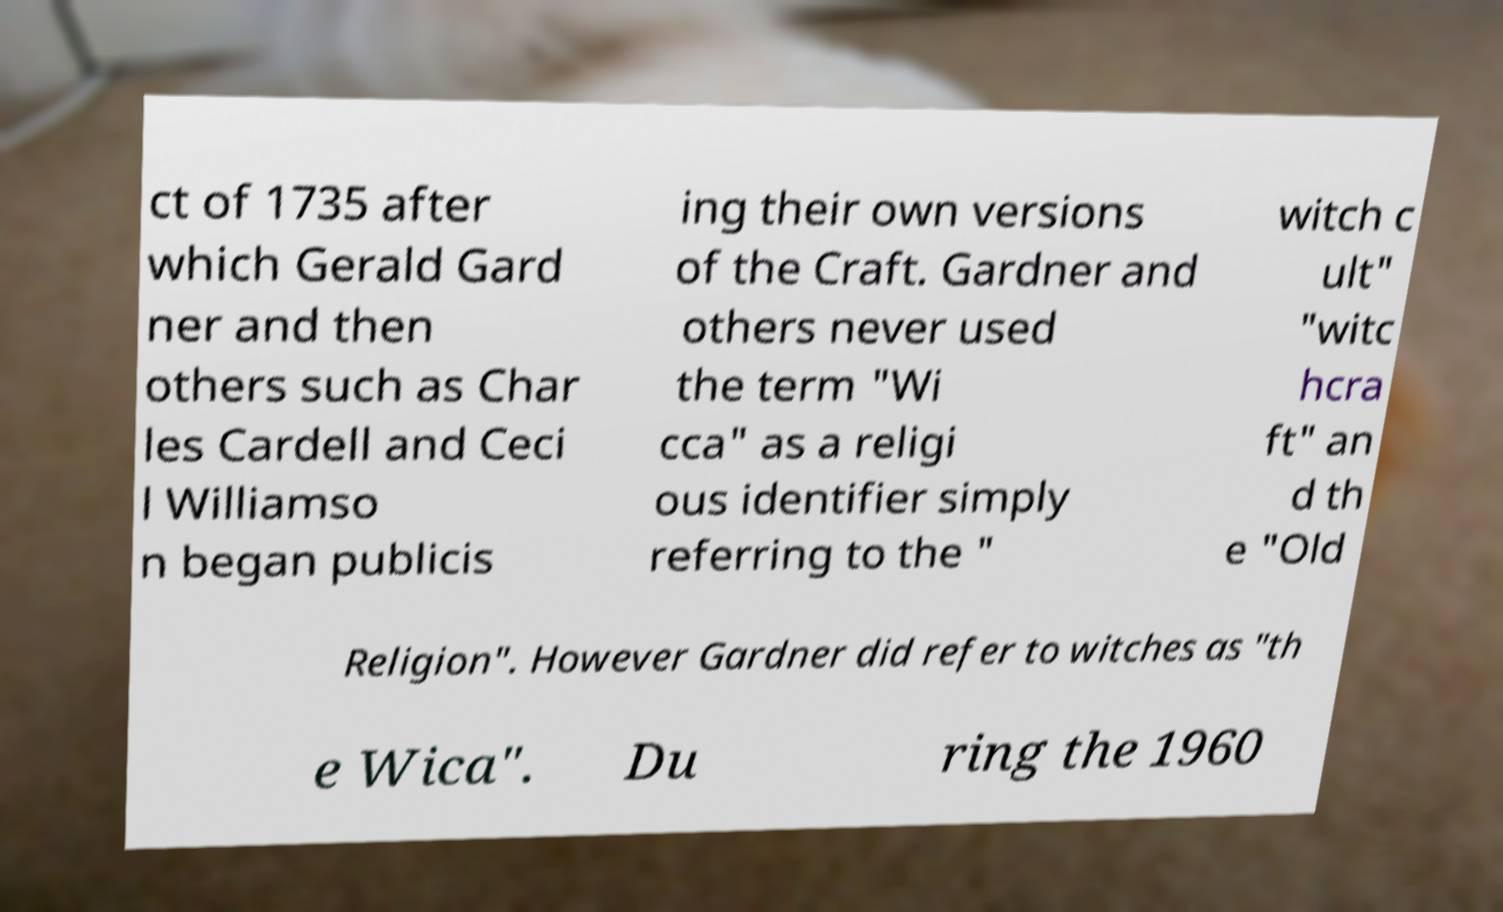Can you accurately transcribe the text from the provided image for me? ct of 1735 after which Gerald Gard ner and then others such as Char les Cardell and Ceci l Williamso n began publicis ing their own versions of the Craft. Gardner and others never used the term "Wi cca" as a religi ous identifier simply referring to the " witch c ult" "witc hcra ft" an d th e "Old Religion". However Gardner did refer to witches as "th e Wica". Du ring the 1960 